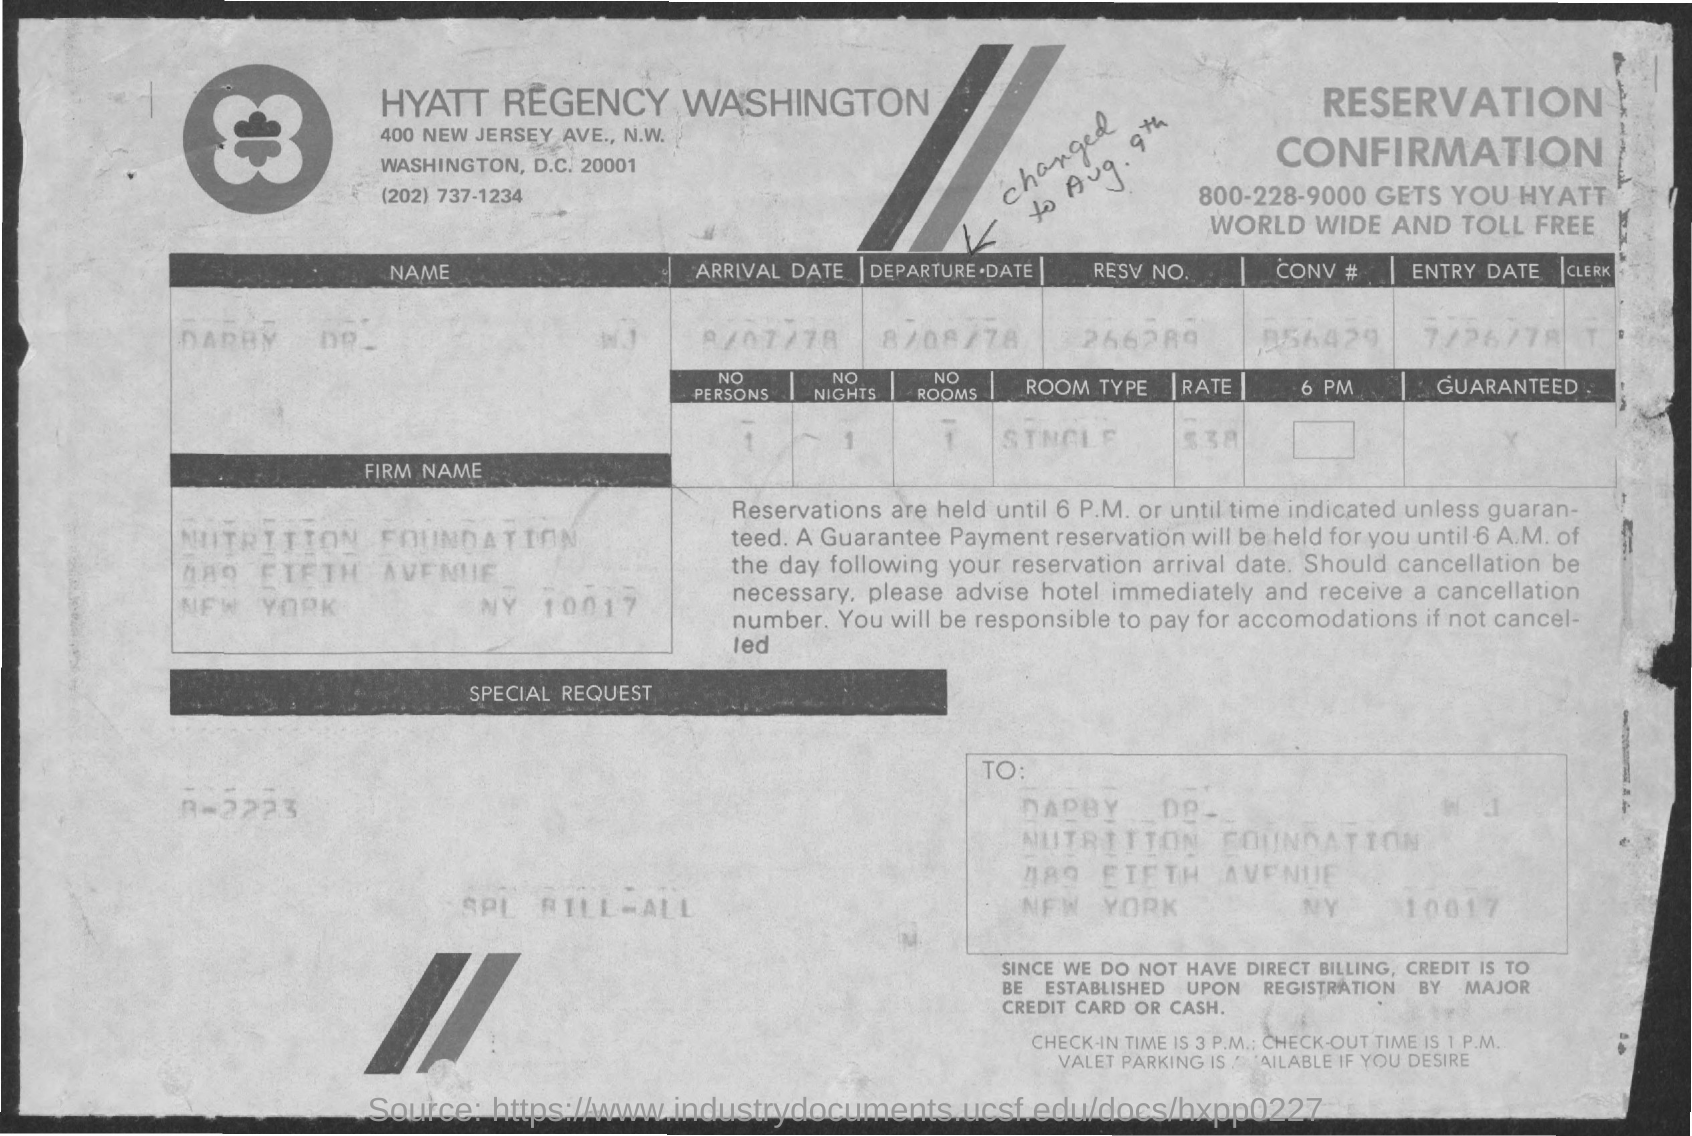what is the entry date mentioned ?
 7/26/78 